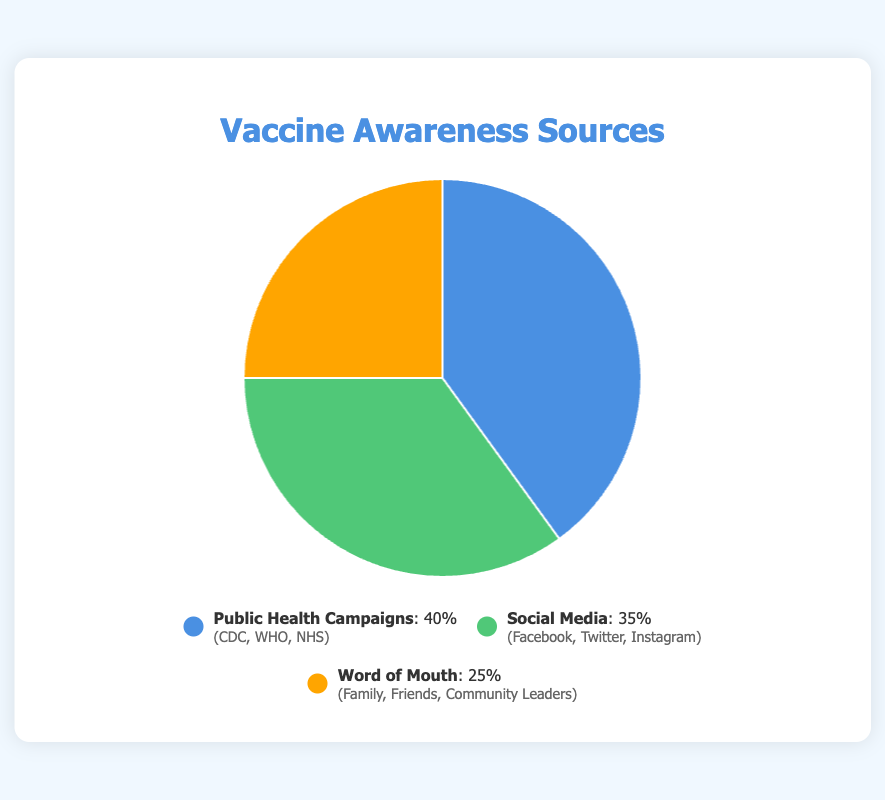what percentage of vaccine awareness is attributed to public health campaigns? The pie chart shows that 40% of vaccine awareness comes from public health campaigns.
Answer: 40% which source of awareness contributes the least? By comparing the percentages on the pie chart, word of mouth has the lowest percentage at 25%.
Answer: Word of Mouth how much higher is the percentage of awareness from public health campaigns compared to word of mouth? Subtract the percentage of word of mouth (25%) from public health campaigns (40%). 40% - 25% = 15%.
Answer: 15% what are the three entities associated with social media awareness according to the chart? The legend detailing the sources shows that awareness through social media involves Facebook, Twitter, and Instagram.
Answer: Facebook, Twitter, Instagram combine the percentages of public health campaigns and social media. how does this combined percentage compare to word of mouth? Adding the percentages of public health campaigns (40%) and social media (35%) gives 75%. Comparing this with word of mouth (25%), the combined percentage is 50% higher.
Answer: 75%, 50% higher if one were to focus on only two sources to maximize awareness, which ones should they choose? The combined percentage of the top two sources, public health campaigns (40%) and social media (35%), is higher than any other combination.
Answer: public health campaigns and social media are the entities for public health campaigns all global organizations? The entities listed for public health campaigns are CDC, WHO, and NHS, all of which are global or national-level organizations.
Answer: Yes what is the average percentage of vaccine awareness across the three sources? Adding up the percentages (40 + 35 + 25) gives 100%, then dividing by 3 gives the average. 100% / 3 ≈ 33.33%.
Answer: 33.33% how many more entities contribute to word of mouth awareness compared to social media awareness? Word of mouth has 3 entities (Family, Friends, Community Leaders) and social media has 3 entities (Facebook, Twitter, Instagram). The number is the same.
Answer: 0 which source has the closest percentage to one-third of the total awareness? One-third of 100% is approximately 33.33%. Social media awareness, at 35%, is the closest to one-third of the total.
Answer: Social Media 